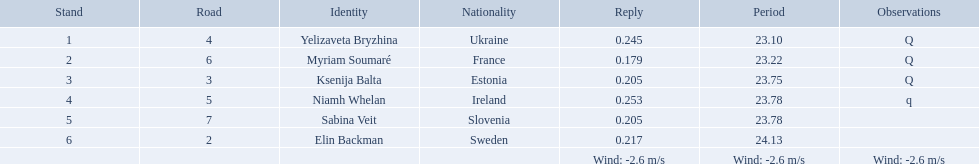What place did elin backman finish the race in? 6. How long did it take him to finish? 24.13. 